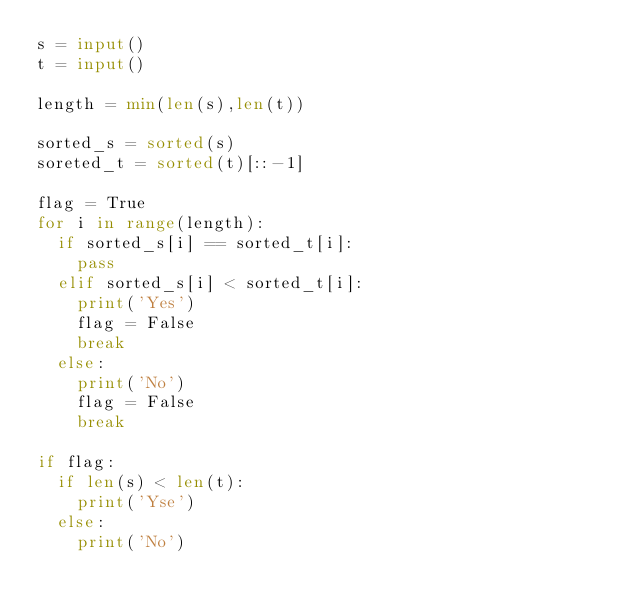<code> <loc_0><loc_0><loc_500><loc_500><_Python_>s = input()
t = input()

length = min(len(s),len(t))

sorted_s = sorted(s)
soreted_t = sorted(t)[::-1]

flag = True
for i in range(length):
  if sorted_s[i] == sorted_t[i]:
    pass
  elif sorted_s[i] < sorted_t[i]:
    print('Yes')
    flag = False
    break
  else:
    print('No')
    flag = False
    break

if flag:
  if len(s) < len(t):
    print('Yse')
  else:
    print('No')
</code> 